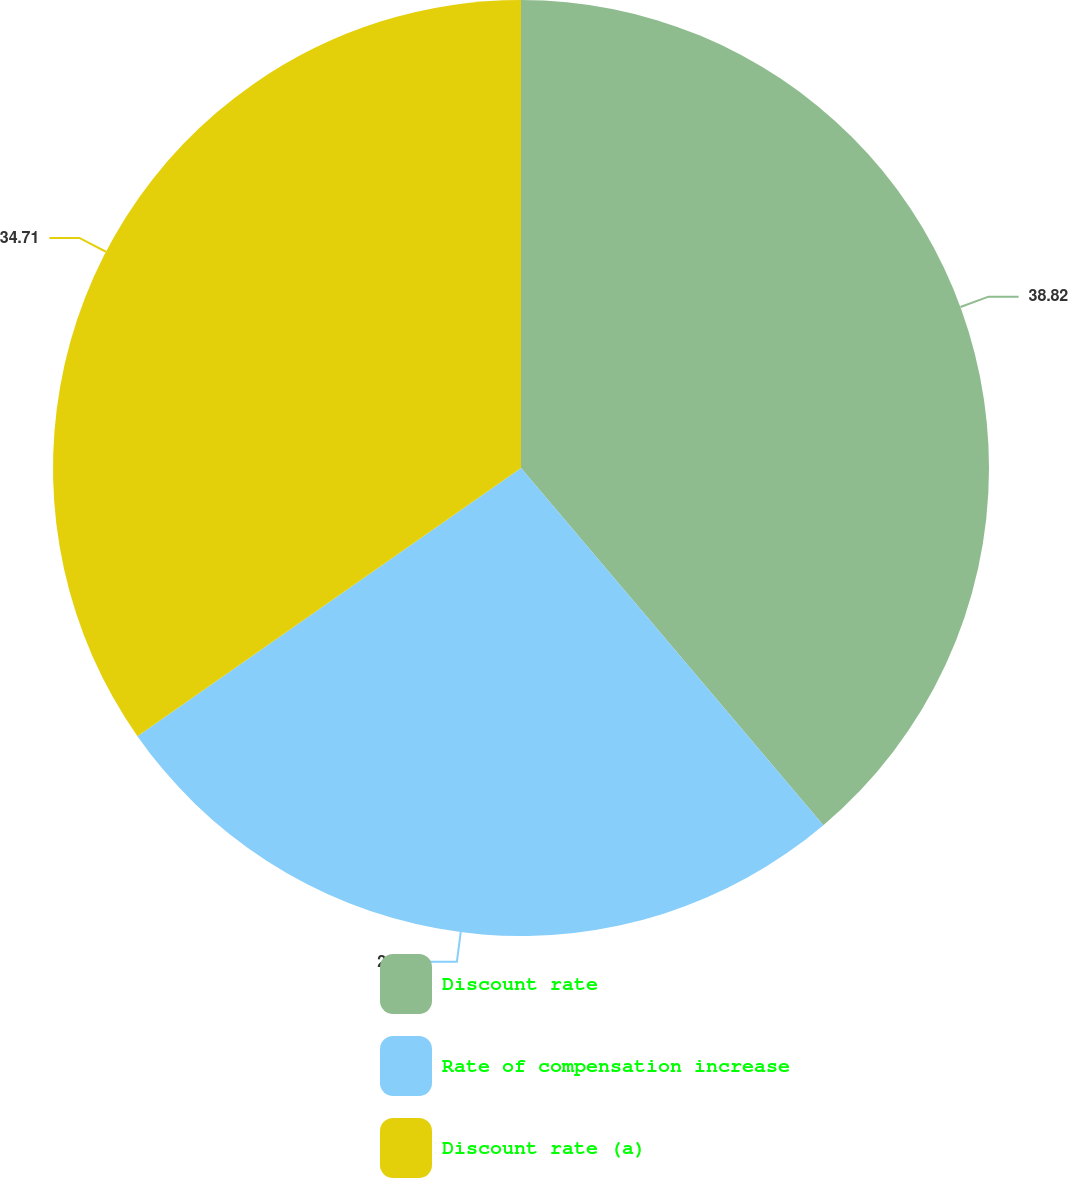<chart> <loc_0><loc_0><loc_500><loc_500><pie_chart><fcel>Discount rate<fcel>Rate of compensation increase<fcel>Discount rate (a)<nl><fcel>38.82%<fcel>26.47%<fcel>34.71%<nl></chart> 